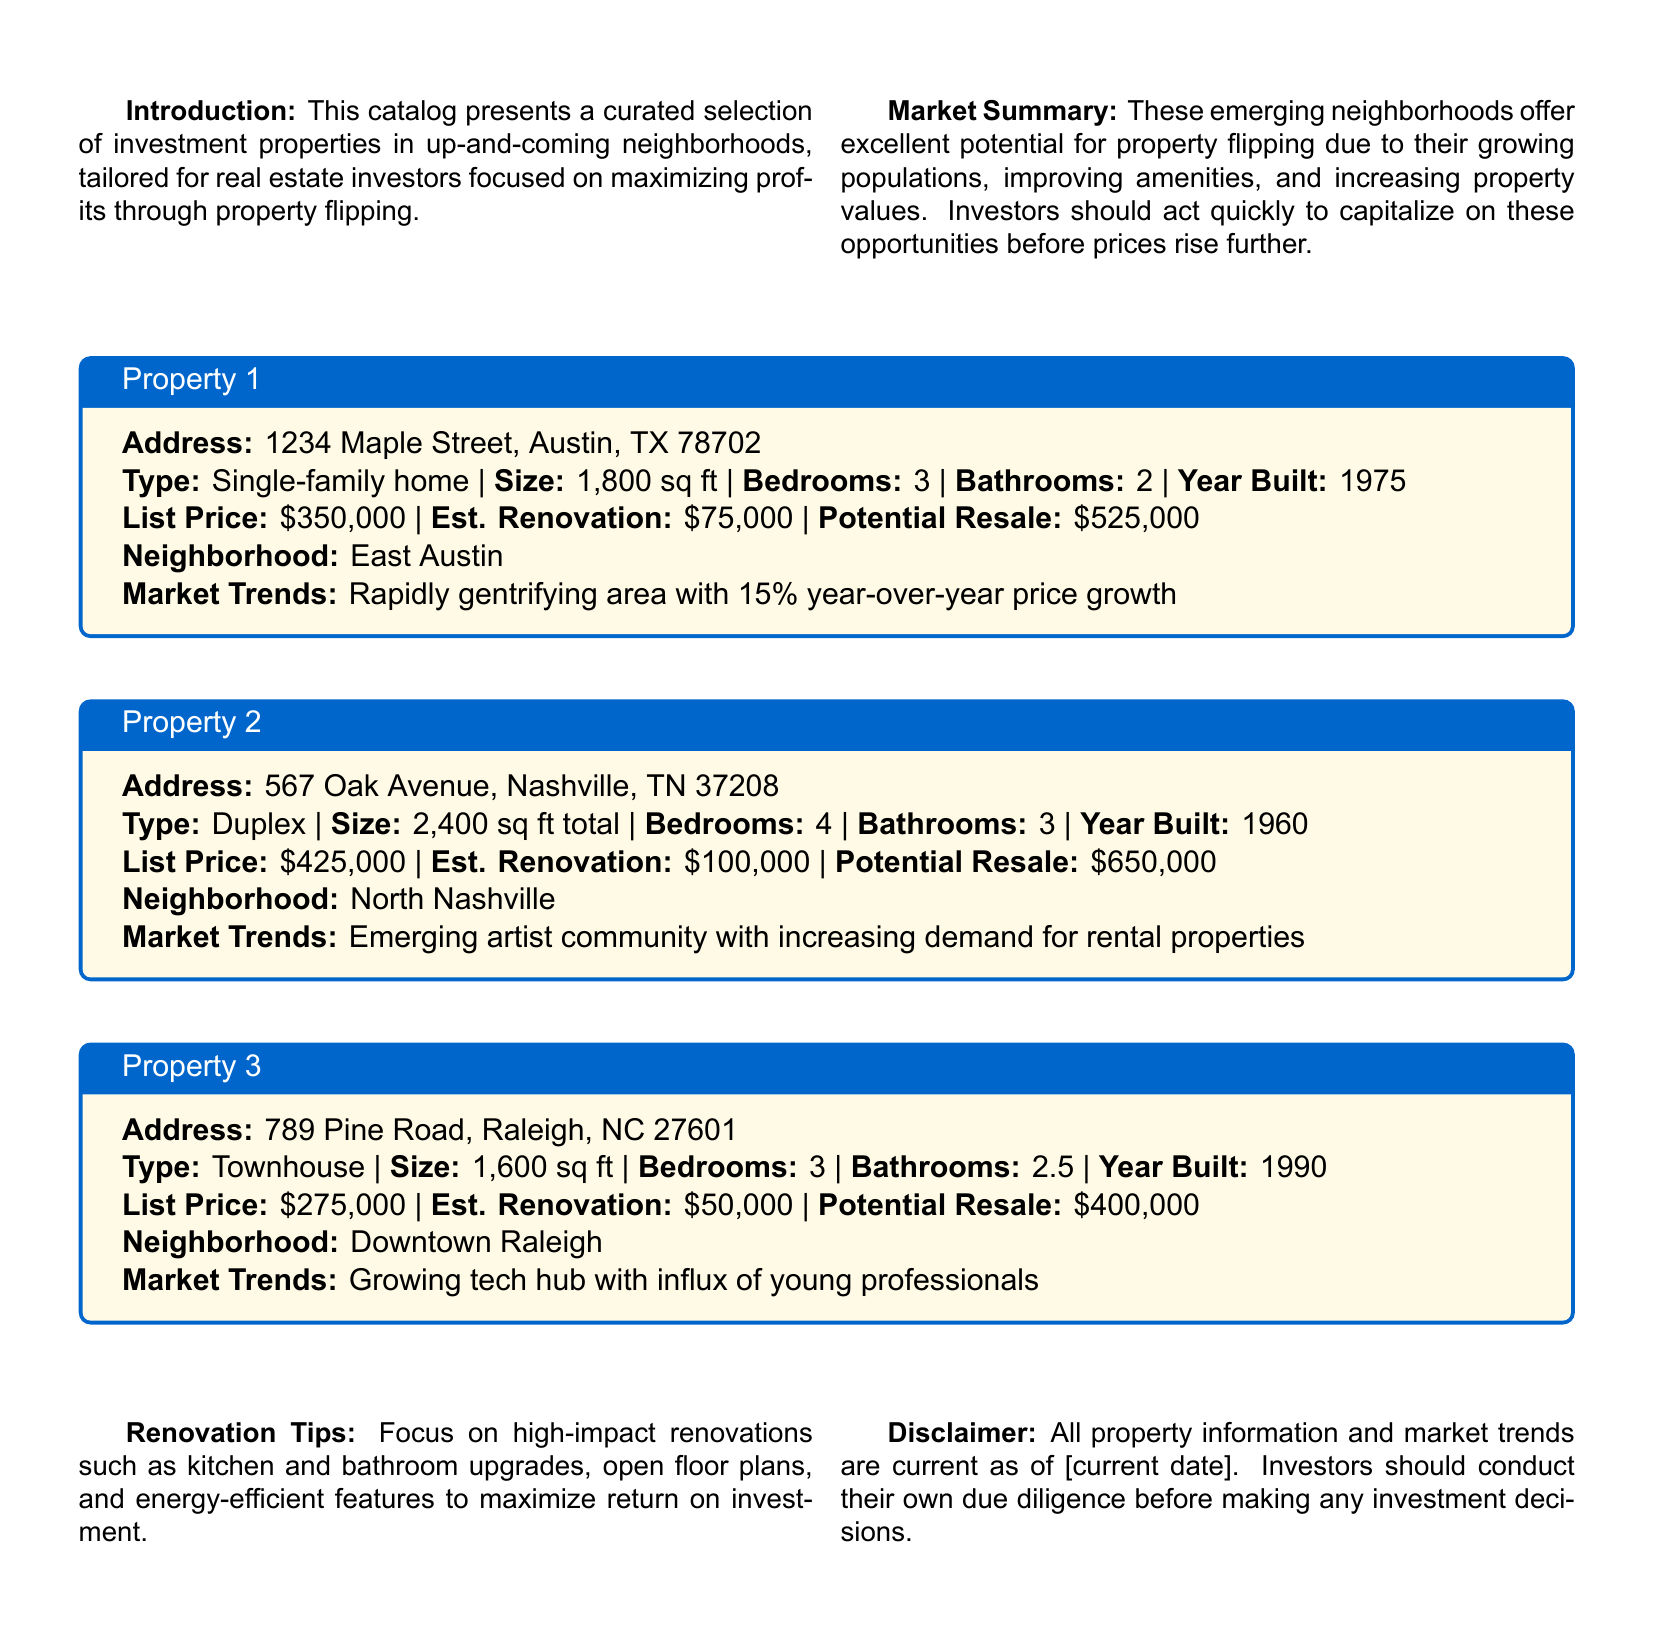what is the list price of Property 1? The list price of Property 1, located at 1234 Maple Street, is provided in the document.
Answer: $350,000 what is the estimated renovation cost of Property 2? The estimated renovation cost of Property 2, located at 567 Oak Avenue, is included in the property details.
Answer: $100,000 what is the potential resale value of Property 3? The potential resale value of Property 3, located at 789 Pine Road, is given in the property details.
Answer: $400,000 which neighborhood is Property 1 located in? The neighborhood for Property 1 is specified in the catalog details for the property.
Answer: East Austin what is the year built of Property 2? The year built for Property 2 is included in the property information.
Answer: 1960 which property has the largest estimated resale value? The potential resale values of each property can be compared to answer this question.
Answer: Property 2 what are the key renovation tips mentioned in the catalog? The catalog provides renovation tips that can enhance the value of the properties, and those tips are summarized in a section.
Answer: kitchen and bathroom upgrades, open floor plans, energy-efficient features which market trend is associated with Property 3? The market trend for Property 3 is elaborated in the property details section.
Answer: Growing tech hub with influx of young professionals what type of document is this? The main purpose of the document and its structure suggest its type, which is aimed at helping investors.
Answer: A comprehensive catalog of potential investment properties 